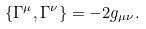Convert formula to latex. <formula><loc_0><loc_0><loc_500><loc_500>\{ \Gamma ^ { \mu } , \Gamma ^ { \nu } \} = - 2 g _ { \mu \nu } .</formula> 